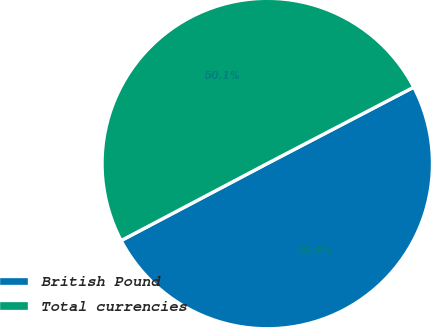Convert chart. <chart><loc_0><loc_0><loc_500><loc_500><pie_chart><fcel>British Pound<fcel>Total currencies<nl><fcel>49.93%<fcel>50.07%<nl></chart> 